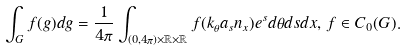Convert formula to latex. <formula><loc_0><loc_0><loc_500><loc_500>\int _ { G } f ( g ) d g = \frac { 1 } { 4 \pi } \int _ { ( 0 , 4 \pi ) \times \mathbb { R } \times \mathbb { R } } f ( k _ { \theta } a _ { s } n _ { x } ) e ^ { s } d \theta d s d x , \, f \in C _ { 0 } ( G ) .</formula> 